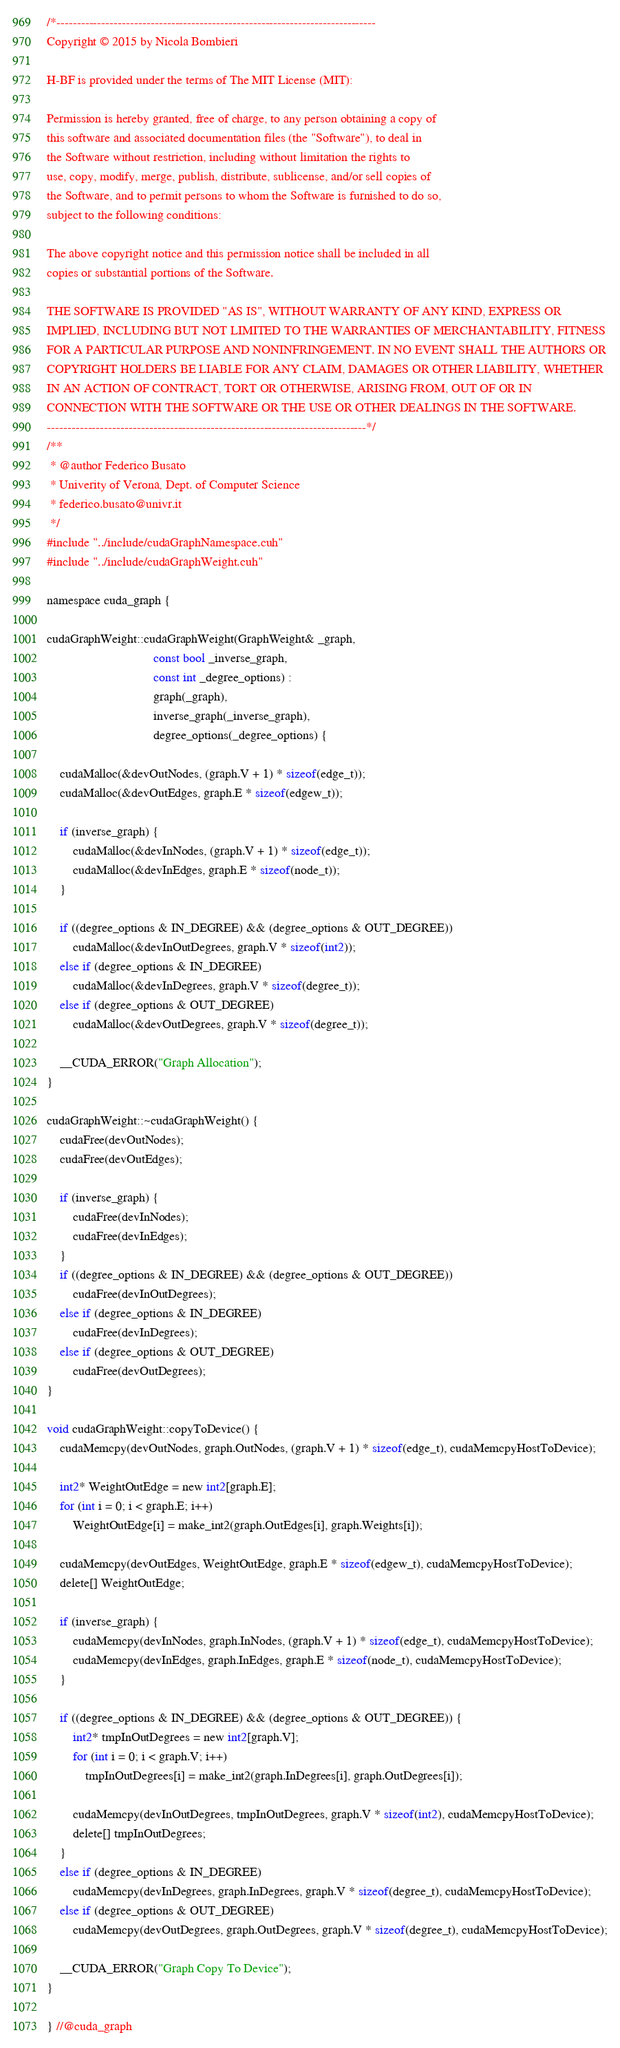Convert code to text. <code><loc_0><loc_0><loc_500><loc_500><_Cuda_>/*------------------------------------------------------------------------------
Copyright © 2015 by Nicola Bombieri

H-BF is provided under the terms of The MIT License (MIT):

Permission is hereby granted, free of charge, to any person obtaining a copy of
this software and associated documentation files (the "Software"), to deal in
the Software without restriction, including without limitation the rights to
use, copy, modify, merge, publish, distribute, sublicense, and/or sell copies of
the Software, and to permit persons to whom the Software is furnished to do so,
subject to the following conditions:

The above copyright notice and this permission notice shall be included in all
copies or substantial portions of the Software.

THE SOFTWARE IS PROVIDED "AS IS", WITHOUT WARRANTY OF ANY KIND, EXPRESS OR
IMPLIED, INCLUDING BUT NOT LIMITED TO THE WARRANTIES OF MERCHANTABILITY, FITNESS
FOR A PARTICULAR PURPOSE AND NONINFRINGEMENT. IN NO EVENT SHALL THE AUTHORS OR
COPYRIGHT HOLDERS BE LIABLE FOR ANY CLAIM, DAMAGES OR OTHER LIABILITY, WHETHER
IN AN ACTION OF CONTRACT, TORT OR OTHERWISE, ARISING FROM, OUT OF OR IN
CONNECTION WITH THE SOFTWARE OR THE USE OR OTHER DEALINGS IN THE SOFTWARE.
------------------------------------------------------------------------------*/
/**
 * @author Federico Busato
 * Univerity of Verona, Dept. of Computer Science
 * federico.busato@univr.it
 */
#include "../include/cudaGraphNamespace.cuh"
#include "../include/cudaGraphWeight.cuh"

namespace cuda_graph {

cudaGraphWeight::cudaGraphWeight(GraphWeight& _graph,
                                 const bool _inverse_graph,
                                 const int _degree_options) :
                                 graph(_graph),
                                 inverse_graph(_inverse_graph),
                                 degree_options(_degree_options) {

	cudaMalloc(&devOutNodes, (graph.V + 1) * sizeof(edge_t));
	cudaMalloc(&devOutEdges, graph.E * sizeof(edgew_t));

    if (inverse_graph) {
        cudaMalloc(&devInNodes, (graph.V + 1) * sizeof(edge_t));
        cudaMalloc(&devInEdges, graph.E * sizeof(node_t));
    }

	if ((degree_options & IN_DEGREE) && (degree_options & OUT_DEGREE))
		cudaMalloc(&devInOutDegrees, graph.V * sizeof(int2));
	else if (degree_options & IN_DEGREE)
		cudaMalloc(&devInDegrees, graph.V * sizeof(degree_t));
	else if (degree_options & OUT_DEGREE)
		cudaMalloc(&devOutDegrees, graph.V * sizeof(degree_t));

	__CUDA_ERROR("Graph Allocation");
}

cudaGraphWeight::~cudaGraphWeight() {
    cudaFree(devOutNodes);
    cudaFree(devOutEdges);

    if (inverse_graph) {
        cudaFree(devInNodes);
        cudaFree(devInEdges);
    }
    if ((degree_options & IN_DEGREE) && (degree_options & OUT_DEGREE))
		cudaFree(devInOutDegrees);
	else if (degree_options & IN_DEGREE)
		cudaFree(devInDegrees);
	else if (degree_options & OUT_DEGREE)
		cudaFree(devOutDegrees);
}

void cudaGraphWeight::copyToDevice() {
	cudaMemcpy(devOutNodes, graph.OutNodes, (graph.V + 1) * sizeof(edge_t), cudaMemcpyHostToDevice);

    int2* WeightOutEdge = new int2[graph.E];
    for (int i = 0; i < graph.E; i++)
        WeightOutEdge[i] = make_int2(graph.OutEdges[i], graph.Weights[i]);

	cudaMemcpy(devOutEdges, WeightOutEdge, graph.E * sizeof(edgew_t), cudaMemcpyHostToDevice);
    delete[] WeightOutEdge;

    if (inverse_graph) {
        cudaMemcpy(devInNodes, graph.InNodes, (graph.V + 1) * sizeof(edge_t), cudaMemcpyHostToDevice);
        cudaMemcpy(devInEdges, graph.InEdges, graph.E * sizeof(node_t), cudaMemcpyHostToDevice);
    }

	if ((degree_options & IN_DEGREE) && (degree_options & OUT_DEGREE)) {
		int2* tmpInOutDegrees = new int2[graph.V];
		for (int i = 0; i < graph.V; i++)
			tmpInOutDegrees[i] = make_int2(graph.InDegrees[i], graph.OutDegrees[i]);

		cudaMemcpy(devInOutDegrees, tmpInOutDegrees, graph.V * sizeof(int2), cudaMemcpyHostToDevice);
		delete[] tmpInOutDegrees;
	}
    else if (degree_options & IN_DEGREE)
		cudaMemcpy(devInDegrees, graph.InDegrees, graph.V * sizeof(degree_t), cudaMemcpyHostToDevice);
	else if (degree_options & OUT_DEGREE)
		cudaMemcpy(devOutDegrees, graph.OutDegrees, graph.V * sizeof(degree_t), cudaMemcpyHostToDevice);

	__CUDA_ERROR("Graph Copy To Device");
}

} //@cuda_graph
</code> 